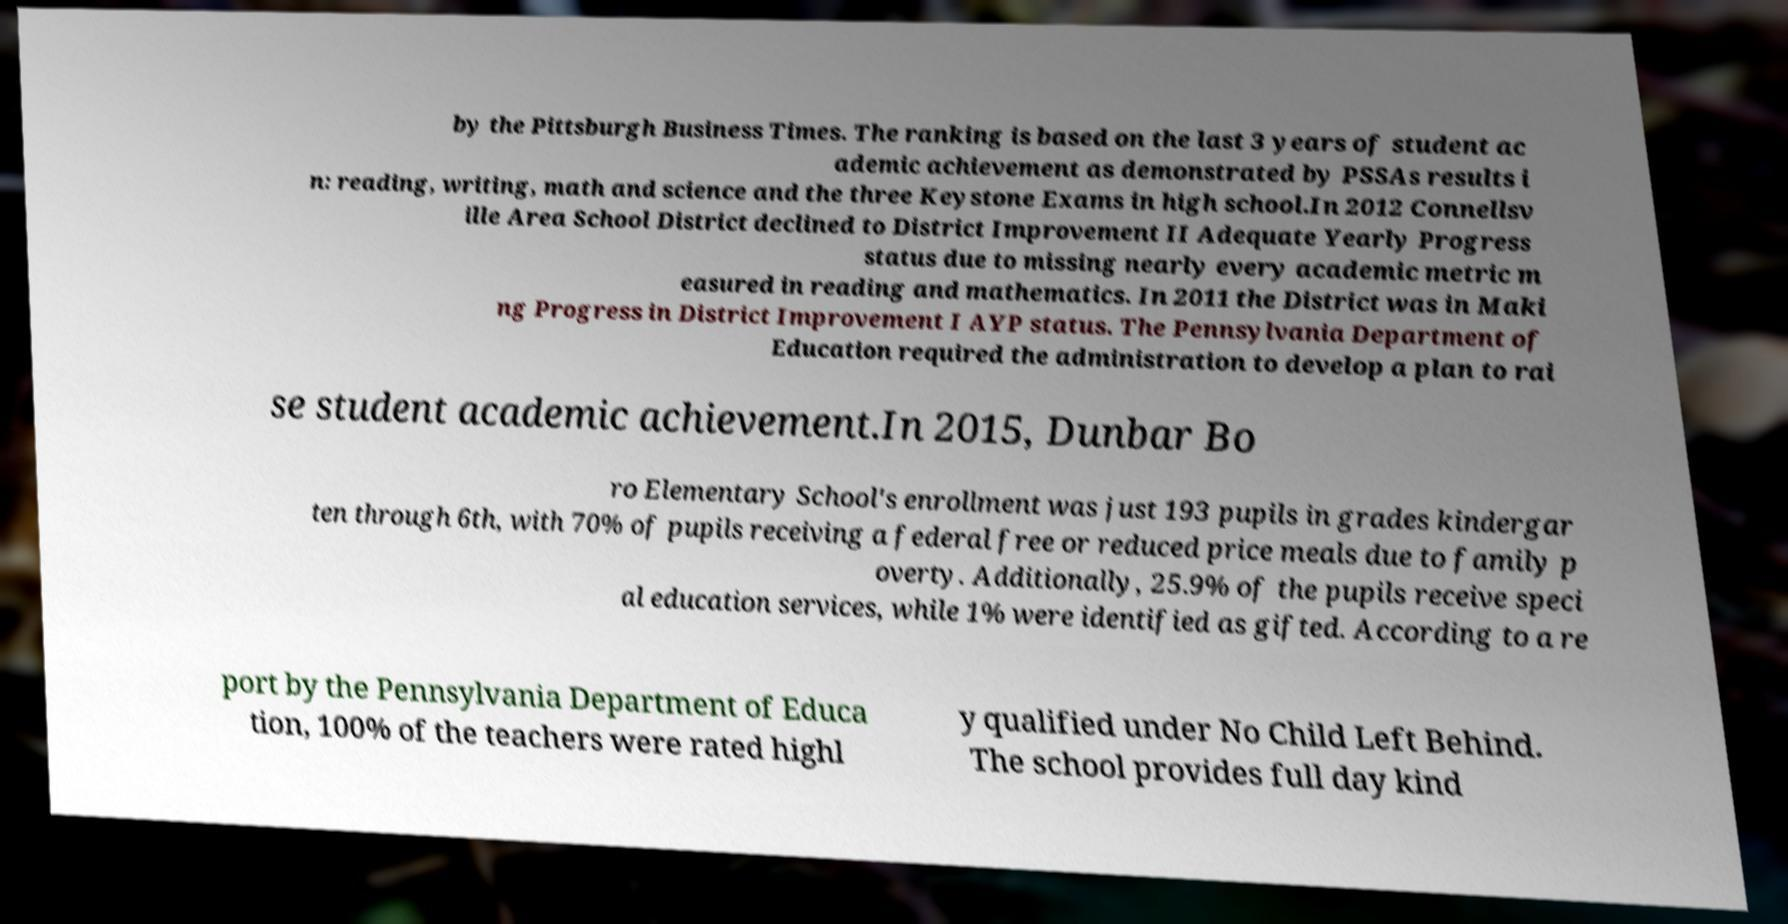There's text embedded in this image that I need extracted. Can you transcribe it verbatim? by the Pittsburgh Business Times. The ranking is based on the last 3 years of student ac ademic achievement as demonstrated by PSSAs results i n: reading, writing, math and science and the three Keystone Exams in high school.In 2012 Connellsv ille Area School District declined to District Improvement II Adequate Yearly Progress status due to missing nearly every academic metric m easured in reading and mathematics. In 2011 the District was in Maki ng Progress in District Improvement I AYP status. The Pennsylvania Department of Education required the administration to develop a plan to rai se student academic achievement.In 2015, Dunbar Bo ro Elementary School's enrollment was just 193 pupils in grades kindergar ten through 6th, with 70% of pupils receiving a federal free or reduced price meals due to family p overty. Additionally, 25.9% of the pupils receive speci al education services, while 1% were identified as gifted. According to a re port by the Pennsylvania Department of Educa tion, 100% of the teachers were rated highl y qualified under No Child Left Behind. The school provides full day kind 